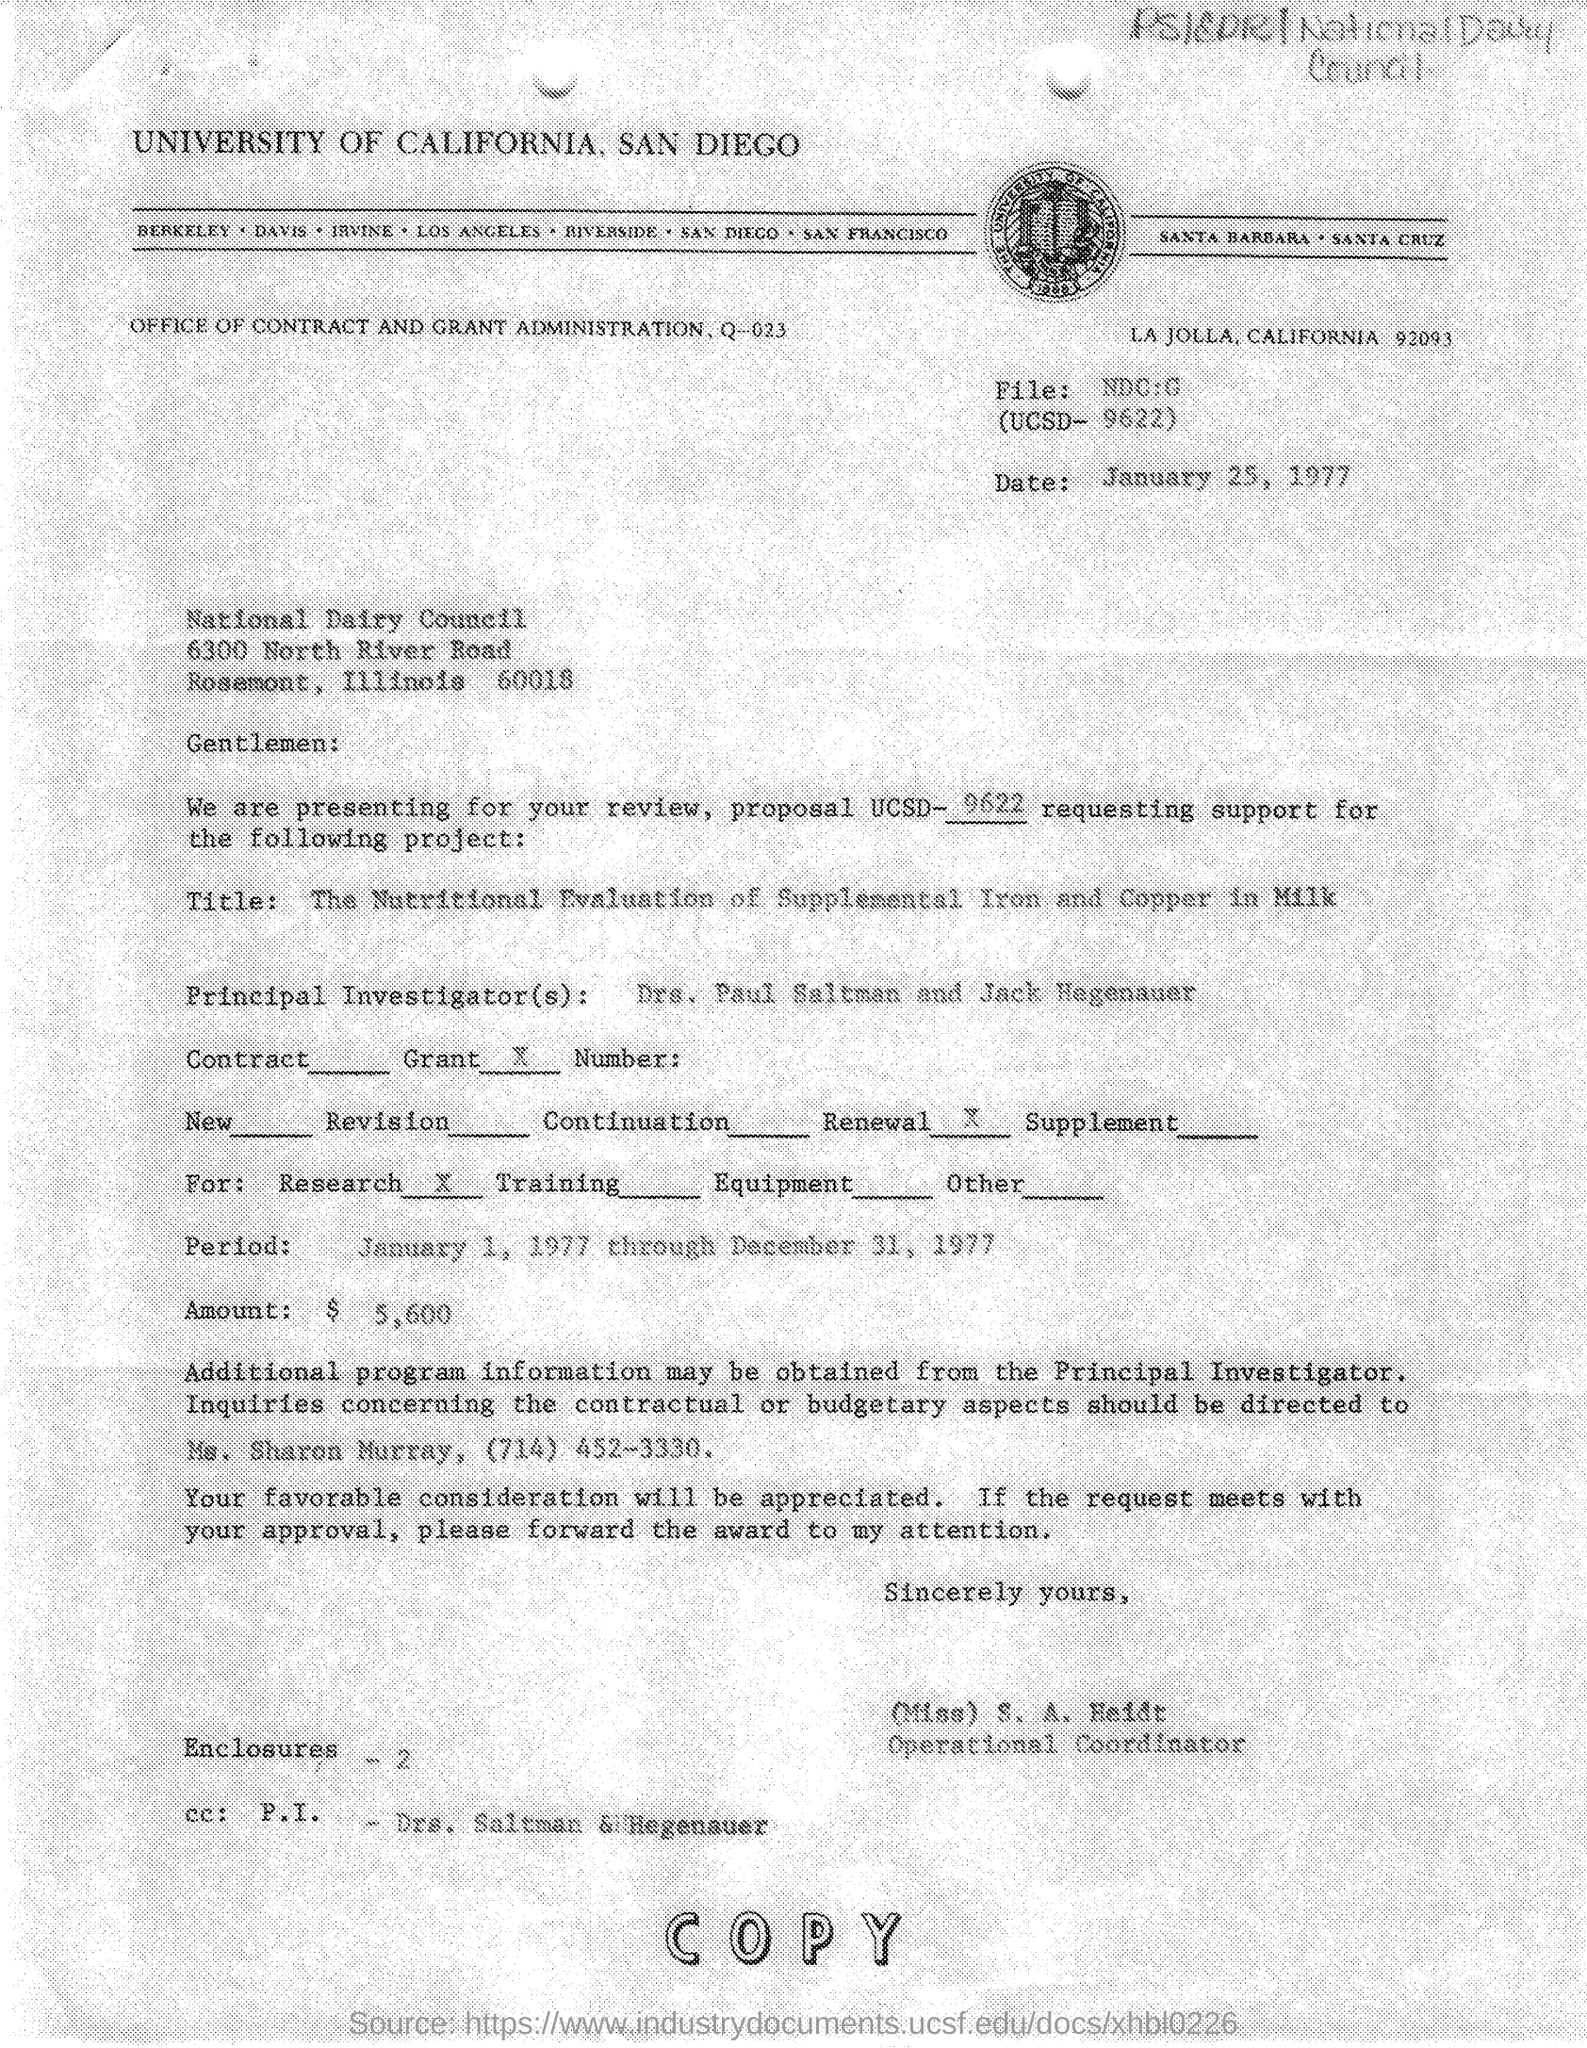What is the date mentioned in the given page ?
Keep it short and to the point. January 25, 1977. What is the ucsd number mentioned in the given letter ?
Provide a short and direct response. 9622. What is the title mentioned in the given letter ?
Your answer should be compact. The Nutritional evaluation of Supplemental Iron and Copper in Milk. Who are the principal investigators mentioned in the given letter ?
Your answer should be compact. Drs. Paul Saltman and Jack Hegenauer. What is the amount mentioned in the given letter ?
Provide a succinct answer. $ 5,600. What is the designation of s.a. heidt ?
Give a very brief answer. Operational coordinator. What is the name of the council mentioned in the given letter ?
Offer a terse response. NATIONAL DAIRY COUNCIL. What is the name of the university mentioned in the given letter ?
Provide a succinct answer. University of california. 